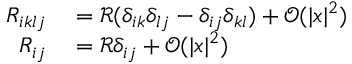<formula> <loc_0><loc_0><loc_500><loc_500>\begin{array} { r l } { R _ { i k l j } } & = \mathcal { R } ( \delta _ { i k } \delta _ { l j } - \delta _ { i j } \delta _ { k l } ) + \mathcal { O } ( | x | ^ { 2 } ) } \\ { R _ { i j } } & = \mathcal { R } \delta _ { i j } + \mathcal { O } ( | x | ^ { 2 } ) } \end{array}</formula> 